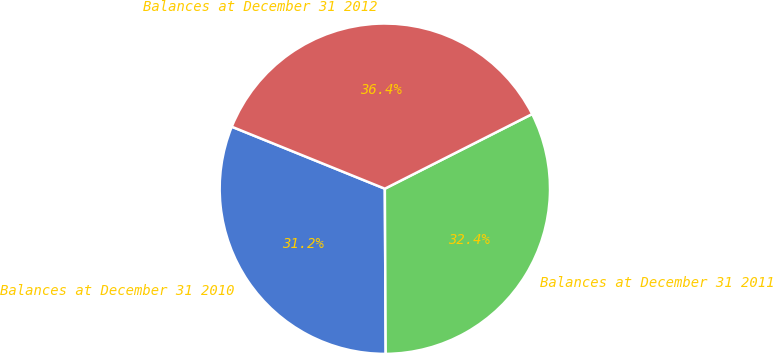Convert chart to OTSL. <chart><loc_0><loc_0><loc_500><loc_500><pie_chart><fcel>Balances at December 31 2010<fcel>Balances at December 31 2011<fcel>Balances at December 31 2012<nl><fcel>31.21%<fcel>32.38%<fcel>36.41%<nl></chart> 